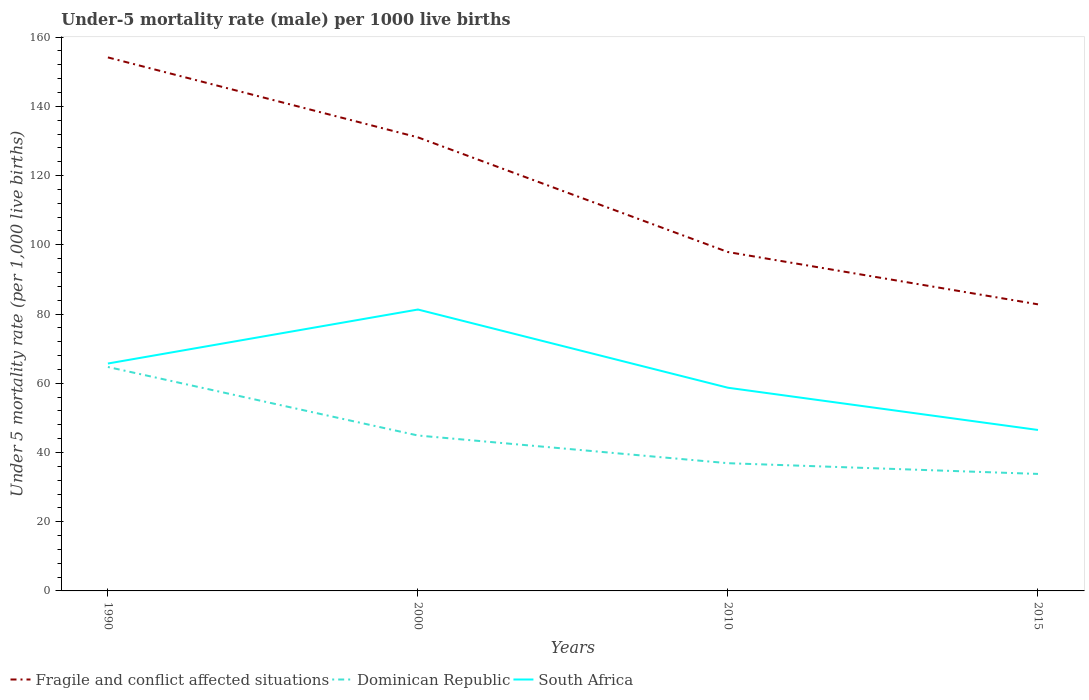How many different coloured lines are there?
Your response must be concise. 3. Does the line corresponding to Dominican Republic intersect with the line corresponding to South Africa?
Your answer should be very brief. No. Across all years, what is the maximum under-five mortality rate in Fragile and conflict affected situations?
Give a very brief answer. 82.79. In which year was the under-five mortality rate in Fragile and conflict affected situations maximum?
Provide a short and direct response. 2015. What is the total under-five mortality rate in South Africa in the graph?
Offer a terse response. 12.2. What is the difference between the highest and the second highest under-five mortality rate in Dominican Republic?
Make the answer very short. 30.9. How many years are there in the graph?
Give a very brief answer. 4. What is the difference between two consecutive major ticks on the Y-axis?
Your response must be concise. 20. How many legend labels are there?
Your answer should be compact. 3. What is the title of the graph?
Offer a terse response. Under-5 mortality rate (male) per 1000 live births. What is the label or title of the Y-axis?
Your answer should be very brief. Under 5 mortality rate (per 1,0 live births). What is the Under 5 mortality rate (per 1,000 live births) in Fragile and conflict affected situations in 1990?
Offer a very short reply. 154.14. What is the Under 5 mortality rate (per 1,000 live births) of Dominican Republic in 1990?
Keep it short and to the point. 64.7. What is the Under 5 mortality rate (per 1,000 live births) in South Africa in 1990?
Give a very brief answer. 65.7. What is the Under 5 mortality rate (per 1,000 live births) in Fragile and conflict affected situations in 2000?
Provide a short and direct response. 131.04. What is the Under 5 mortality rate (per 1,000 live births) of Dominican Republic in 2000?
Provide a short and direct response. 44.9. What is the Under 5 mortality rate (per 1,000 live births) in South Africa in 2000?
Offer a terse response. 81.3. What is the Under 5 mortality rate (per 1,000 live births) of Fragile and conflict affected situations in 2010?
Your response must be concise. 97.9. What is the Under 5 mortality rate (per 1,000 live births) in Dominican Republic in 2010?
Give a very brief answer. 36.9. What is the Under 5 mortality rate (per 1,000 live births) of South Africa in 2010?
Your answer should be very brief. 58.7. What is the Under 5 mortality rate (per 1,000 live births) in Fragile and conflict affected situations in 2015?
Make the answer very short. 82.79. What is the Under 5 mortality rate (per 1,000 live births) of Dominican Republic in 2015?
Ensure brevity in your answer.  33.8. What is the Under 5 mortality rate (per 1,000 live births) in South Africa in 2015?
Your response must be concise. 46.5. Across all years, what is the maximum Under 5 mortality rate (per 1,000 live births) in Fragile and conflict affected situations?
Your response must be concise. 154.14. Across all years, what is the maximum Under 5 mortality rate (per 1,000 live births) in Dominican Republic?
Your answer should be very brief. 64.7. Across all years, what is the maximum Under 5 mortality rate (per 1,000 live births) in South Africa?
Your answer should be very brief. 81.3. Across all years, what is the minimum Under 5 mortality rate (per 1,000 live births) in Fragile and conflict affected situations?
Ensure brevity in your answer.  82.79. Across all years, what is the minimum Under 5 mortality rate (per 1,000 live births) in Dominican Republic?
Your response must be concise. 33.8. Across all years, what is the minimum Under 5 mortality rate (per 1,000 live births) of South Africa?
Give a very brief answer. 46.5. What is the total Under 5 mortality rate (per 1,000 live births) in Fragile and conflict affected situations in the graph?
Keep it short and to the point. 465.87. What is the total Under 5 mortality rate (per 1,000 live births) in Dominican Republic in the graph?
Provide a succinct answer. 180.3. What is the total Under 5 mortality rate (per 1,000 live births) in South Africa in the graph?
Provide a short and direct response. 252.2. What is the difference between the Under 5 mortality rate (per 1,000 live births) of Fragile and conflict affected situations in 1990 and that in 2000?
Provide a succinct answer. 23.1. What is the difference between the Under 5 mortality rate (per 1,000 live births) in Dominican Republic in 1990 and that in 2000?
Your response must be concise. 19.8. What is the difference between the Under 5 mortality rate (per 1,000 live births) of South Africa in 1990 and that in 2000?
Ensure brevity in your answer.  -15.6. What is the difference between the Under 5 mortality rate (per 1,000 live births) in Fragile and conflict affected situations in 1990 and that in 2010?
Ensure brevity in your answer.  56.23. What is the difference between the Under 5 mortality rate (per 1,000 live births) of Dominican Republic in 1990 and that in 2010?
Your response must be concise. 27.8. What is the difference between the Under 5 mortality rate (per 1,000 live births) of South Africa in 1990 and that in 2010?
Give a very brief answer. 7. What is the difference between the Under 5 mortality rate (per 1,000 live births) in Fragile and conflict affected situations in 1990 and that in 2015?
Offer a terse response. 71.34. What is the difference between the Under 5 mortality rate (per 1,000 live births) in Dominican Republic in 1990 and that in 2015?
Ensure brevity in your answer.  30.9. What is the difference between the Under 5 mortality rate (per 1,000 live births) of Fragile and conflict affected situations in 2000 and that in 2010?
Offer a terse response. 33.13. What is the difference between the Under 5 mortality rate (per 1,000 live births) in Dominican Republic in 2000 and that in 2010?
Offer a very short reply. 8. What is the difference between the Under 5 mortality rate (per 1,000 live births) in South Africa in 2000 and that in 2010?
Your response must be concise. 22.6. What is the difference between the Under 5 mortality rate (per 1,000 live births) of Fragile and conflict affected situations in 2000 and that in 2015?
Provide a succinct answer. 48.24. What is the difference between the Under 5 mortality rate (per 1,000 live births) of South Africa in 2000 and that in 2015?
Provide a succinct answer. 34.8. What is the difference between the Under 5 mortality rate (per 1,000 live births) in Fragile and conflict affected situations in 2010 and that in 2015?
Provide a short and direct response. 15.11. What is the difference between the Under 5 mortality rate (per 1,000 live births) in Dominican Republic in 2010 and that in 2015?
Provide a succinct answer. 3.1. What is the difference between the Under 5 mortality rate (per 1,000 live births) of Fragile and conflict affected situations in 1990 and the Under 5 mortality rate (per 1,000 live births) of Dominican Republic in 2000?
Offer a terse response. 109.24. What is the difference between the Under 5 mortality rate (per 1,000 live births) in Fragile and conflict affected situations in 1990 and the Under 5 mortality rate (per 1,000 live births) in South Africa in 2000?
Offer a very short reply. 72.84. What is the difference between the Under 5 mortality rate (per 1,000 live births) in Dominican Republic in 1990 and the Under 5 mortality rate (per 1,000 live births) in South Africa in 2000?
Your answer should be very brief. -16.6. What is the difference between the Under 5 mortality rate (per 1,000 live births) of Fragile and conflict affected situations in 1990 and the Under 5 mortality rate (per 1,000 live births) of Dominican Republic in 2010?
Make the answer very short. 117.24. What is the difference between the Under 5 mortality rate (per 1,000 live births) of Fragile and conflict affected situations in 1990 and the Under 5 mortality rate (per 1,000 live births) of South Africa in 2010?
Provide a short and direct response. 95.44. What is the difference between the Under 5 mortality rate (per 1,000 live births) in Dominican Republic in 1990 and the Under 5 mortality rate (per 1,000 live births) in South Africa in 2010?
Your answer should be very brief. 6. What is the difference between the Under 5 mortality rate (per 1,000 live births) in Fragile and conflict affected situations in 1990 and the Under 5 mortality rate (per 1,000 live births) in Dominican Republic in 2015?
Provide a succinct answer. 120.34. What is the difference between the Under 5 mortality rate (per 1,000 live births) of Fragile and conflict affected situations in 1990 and the Under 5 mortality rate (per 1,000 live births) of South Africa in 2015?
Your response must be concise. 107.64. What is the difference between the Under 5 mortality rate (per 1,000 live births) of Fragile and conflict affected situations in 2000 and the Under 5 mortality rate (per 1,000 live births) of Dominican Republic in 2010?
Your response must be concise. 94.14. What is the difference between the Under 5 mortality rate (per 1,000 live births) of Fragile and conflict affected situations in 2000 and the Under 5 mortality rate (per 1,000 live births) of South Africa in 2010?
Provide a succinct answer. 72.34. What is the difference between the Under 5 mortality rate (per 1,000 live births) in Dominican Republic in 2000 and the Under 5 mortality rate (per 1,000 live births) in South Africa in 2010?
Provide a short and direct response. -13.8. What is the difference between the Under 5 mortality rate (per 1,000 live births) of Fragile and conflict affected situations in 2000 and the Under 5 mortality rate (per 1,000 live births) of Dominican Republic in 2015?
Your answer should be very brief. 97.24. What is the difference between the Under 5 mortality rate (per 1,000 live births) of Fragile and conflict affected situations in 2000 and the Under 5 mortality rate (per 1,000 live births) of South Africa in 2015?
Provide a succinct answer. 84.54. What is the difference between the Under 5 mortality rate (per 1,000 live births) of Dominican Republic in 2000 and the Under 5 mortality rate (per 1,000 live births) of South Africa in 2015?
Provide a succinct answer. -1.6. What is the difference between the Under 5 mortality rate (per 1,000 live births) of Fragile and conflict affected situations in 2010 and the Under 5 mortality rate (per 1,000 live births) of Dominican Republic in 2015?
Provide a short and direct response. 64.1. What is the difference between the Under 5 mortality rate (per 1,000 live births) of Fragile and conflict affected situations in 2010 and the Under 5 mortality rate (per 1,000 live births) of South Africa in 2015?
Your answer should be compact. 51.4. What is the average Under 5 mortality rate (per 1,000 live births) of Fragile and conflict affected situations per year?
Offer a terse response. 116.47. What is the average Under 5 mortality rate (per 1,000 live births) in Dominican Republic per year?
Provide a short and direct response. 45.08. What is the average Under 5 mortality rate (per 1,000 live births) of South Africa per year?
Make the answer very short. 63.05. In the year 1990, what is the difference between the Under 5 mortality rate (per 1,000 live births) in Fragile and conflict affected situations and Under 5 mortality rate (per 1,000 live births) in Dominican Republic?
Your answer should be compact. 89.44. In the year 1990, what is the difference between the Under 5 mortality rate (per 1,000 live births) of Fragile and conflict affected situations and Under 5 mortality rate (per 1,000 live births) of South Africa?
Offer a very short reply. 88.44. In the year 1990, what is the difference between the Under 5 mortality rate (per 1,000 live births) of Dominican Republic and Under 5 mortality rate (per 1,000 live births) of South Africa?
Offer a terse response. -1. In the year 2000, what is the difference between the Under 5 mortality rate (per 1,000 live births) of Fragile and conflict affected situations and Under 5 mortality rate (per 1,000 live births) of Dominican Republic?
Give a very brief answer. 86.14. In the year 2000, what is the difference between the Under 5 mortality rate (per 1,000 live births) of Fragile and conflict affected situations and Under 5 mortality rate (per 1,000 live births) of South Africa?
Offer a very short reply. 49.74. In the year 2000, what is the difference between the Under 5 mortality rate (per 1,000 live births) of Dominican Republic and Under 5 mortality rate (per 1,000 live births) of South Africa?
Your answer should be compact. -36.4. In the year 2010, what is the difference between the Under 5 mortality rate (per 1,000 live births) of Fragile and conflict affected situations and Under 5 mortality rate (per 1,000 live births) of Dominican Republic?
Your answer should be very brief. 61. In the year 2010, what is the difference between the Under 5 mortality rate (per 1,000 live births) in Fragile and conflict affected situations and Under 5 mortality rate (per 1,000 live births) in South Africa?
Offer a terse response. 39.2. In the year 2010, what is the difference between the Under 5 mortality rate (per 1,000 live births) of Dominican Republic and Under 5 mortality rate (per 1,000 live births) of South Africa?
Offer a terse response. -21.8. In the year 2015, what is the difference between the Under 5 mortality rate (per 1,000 live births) of Fragile and conflict affected situations and Under 5 mortality rate (per 1,000 live births) of Dominican Republic?
Give a very brief answer. 48.99. In the year 2015, what is the difference between the Under 5 mortality rate (per 1,000 live births) in Fragile and conflict affected situations and Under 5 mortality rate (per 1,000 live births) in South Africa?
Make the answer very short. 36.29. In the year 2015, what is the difference between the Under 5 mortality rate (per 1,000 live births) of Dominican Republic and Under 5 mortality rate (per 1,000 live births) of South Africa?
Offer a terse response. -12.7. What is the ratio of the Under 5 mortality rate (per 1,000 live births) of Fragile and conflict affected situations in 1990 to that in 2000?
Your response must be concise. 1.18. What is the ratio of the Under 5 mortality rate (per 1,000 live births) of Dominican Republic in 1990 to that in 2000?
Ensure brevity in your answer.  1.44. What is the ratio of the Under 5 mortality rate (per 1,000 live births) in South Africa in 1990 to that in 2000?
Offer a terse response. 0.81. What is the ratio of the Under 5 mortality rate (per 1,000 live births) in Fragile and conflict affected situations in 1990 to that in 2010?
Offer a very short reply. 1.57. What is the ratio of the Under 5 mortality rate (per 1,000 live births) in Dominican Republic in 1990 to that in 2010?
Offer a terse response. 1.75. What is the ratio of the Under 5 mortality rate (per 1,000 live births) in South Africa in 1990 to that in 2010?
Offer a very short reply. 1.12. What is the ratio of the Under 5 mortality rate (per 1,000 live births) in Fragile and conflict affected situations in 1990 to that in 2015?
Offer a terse response. 1.86. What is the ratio of the Under 5 mortality rate (per 1,000 live births) in Dominican Republic in 1990 to that in 2015?
Keep it short and to the point. 1.91. What is the ratio of the Under 5 mortality rate (per 1,000 live births) in South Africa in 1990 to that in 2015?
Make the answer very short. 1.41. What is the ratio of the Under 5 mortality rate (per 1,000 live births) of Fragile and conflict affected situations in 2000 to that in 2010?
Provide a succinct answer. 1.34. What is the ratio of the Under 5 mortality rate (per 1,000 live births) in Dominican Republic in 2000 to that in 2010?
Offer a terse response. 1.22. What is the ratio of the Under 5 mortality rate (per 1,000 live births) of South Africa in 2000 to that in 2010?
Offer a very short reply. 1.39. What is the ratio of the Under 5 mortality rate (per 1,000 live births) in Fragile and conflict affected situations in 2000 to that in 2015?
Make the answer very short. 1.58. What is the ratio of the Under 5 mortality rate (per 1,000 live births) of Dominican Republic in 2000 to that in 2015?
Keep it short and to the point. 1.33. What is the ratio of the Under 5 mortality rate (per 1,000 live births) in South Africa in 2000 to that in 2015?
Keep it short and to the point. 1.75. What is the ratio of the Under 5 mortality rate (per 1,000 live births) of Fragile and conflict affected situations in 2010 to that in 2015?
Provide a short and direct response. 1.18. What is the ratio of the Under 5 mortality rate (per 1,000 live births) in Dominican Republic in 2010 to that in 2015?
Give a very brief answer. 1.09. What is the ratio of the Under 5 mortality rate (per 1,000 live births) of South Africa in 2010 to that in 2015?
Your answer should be very brief. 1.26. What is the difference between the highest and the second highest Under 5 mortality rate (per 1,000 live births) in Fragile and conflict affected situations?
Keep it short and to the point. 23.1. What is the difference between the highest and the second highest Under 5 mortality rate (per 1,000 live births) in Dominican Republic?
Offer a very short reply. 19.8. What is the difference between the highest and the lowest Under 5 mortality rate (per 1,000 live births) in Fragile and conflict affected situations?
Offer a terse response. 71.34. What is the difference between the highest and the lowest Under 5 mortality rate (per 1,000 live births) in Dominican Republic?
Offer a terse response. 30.9. What is the difference between the highest and the lowest Under 5 mortality rate (per 1,000 live births) of South Africa?
Offer a very short reply. 34.8. 